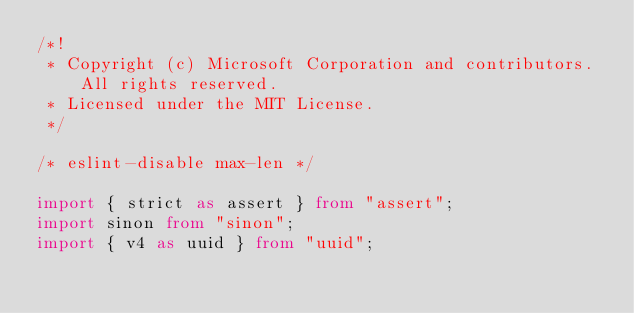Convert code to text. <code><loc_0><loc_0><loc_500><loc_500><_TypeScript_>/*!
 * Copyright (c) Microsoft Corporation and contributors. All rights reserved.
 * Licensed under the MIT License.
 */

/* eslint-disable max-len */

import { strict as assert } from "assert";
import sinon from "sinon";
import { v4 as uuid } from "uuid";</code> 